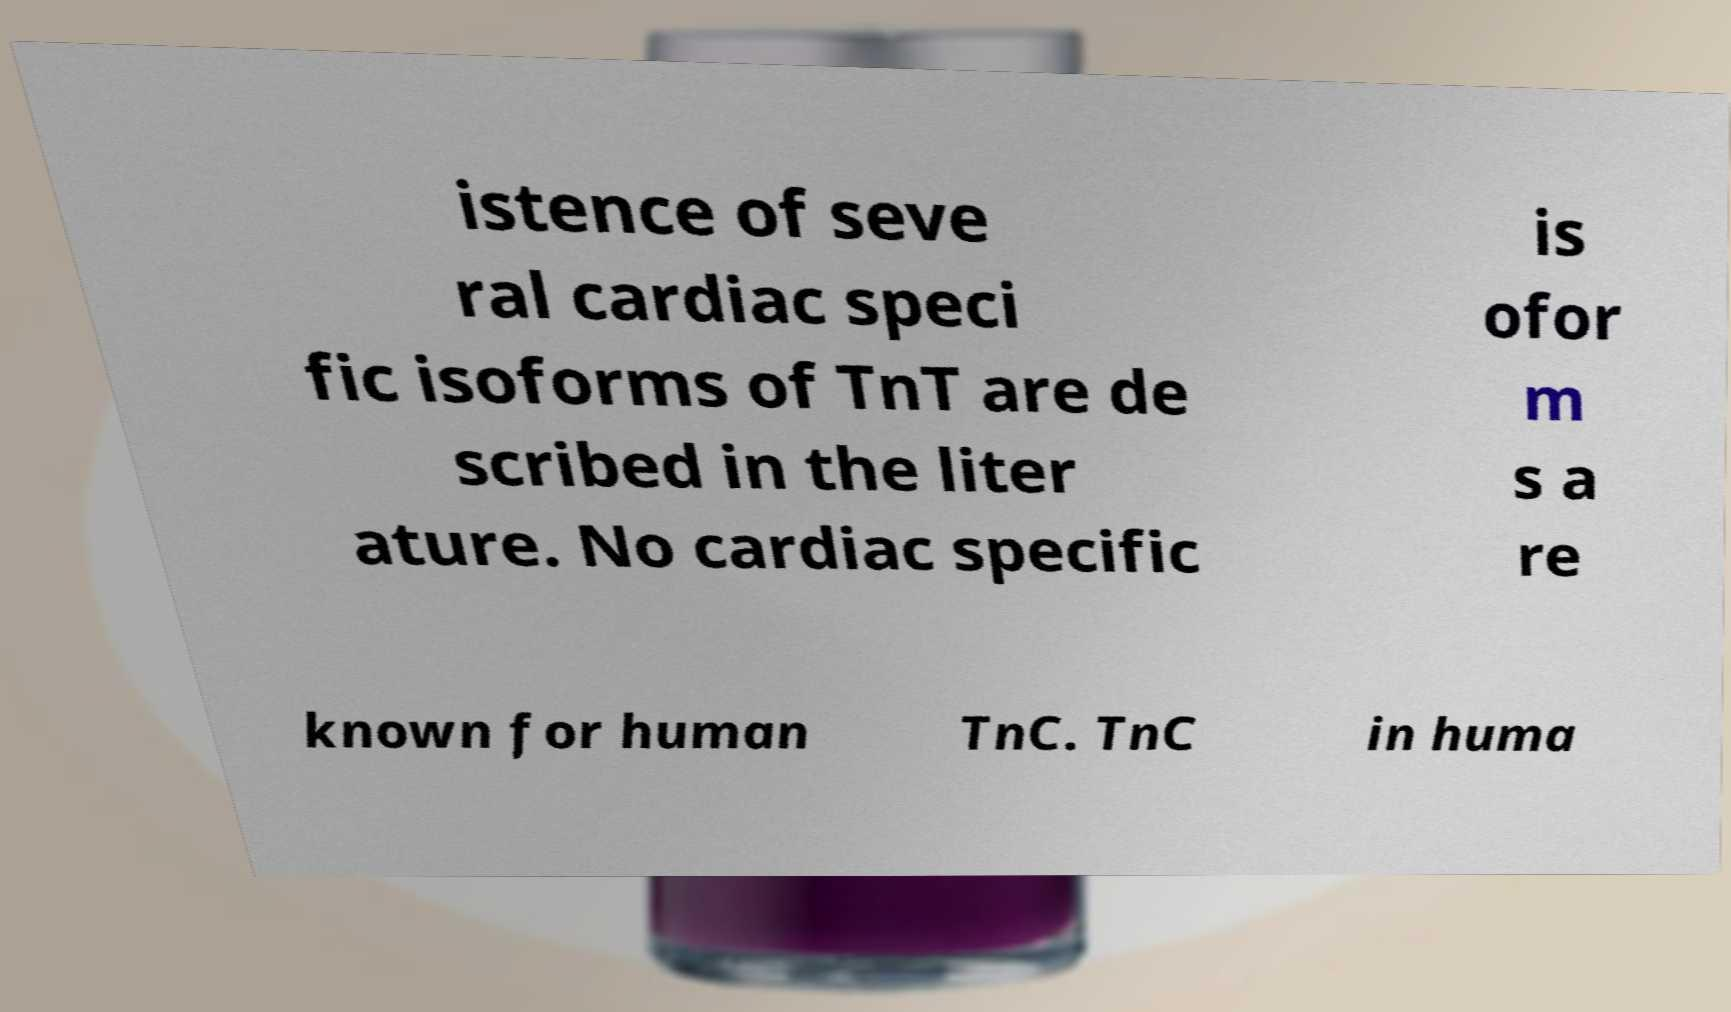Could you extract and type out the text from this image? istence of seve ral cardiac speci fic isoforms of TnT are de scribed in the liter ature. No cardiac specific is ofor m s a re known for human TnC. TnC in huma 